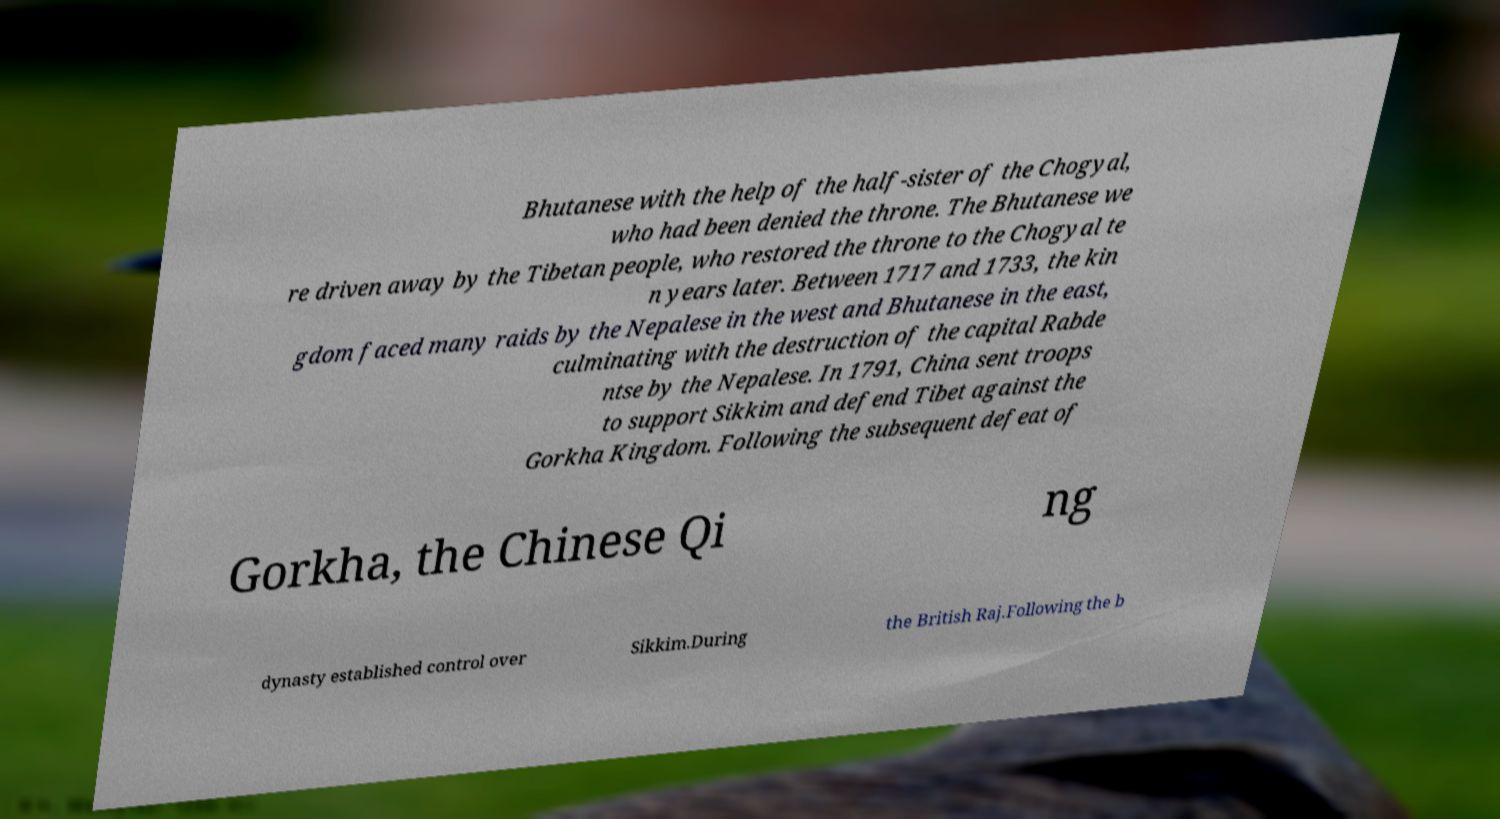I need the written content from this picture converted into text. Can you do that? Bhutanese with the help of the half-sister of the Chogyal, who had been denied the throne. The Bhutanese we re driven away by the Tibetan people, who restored the throne to the Chogyal te n years later. Between 1717 and 1733, the kin gdom faced many raids by the Nepalese in the west and Bhutanese in the east, culminating with the destruction of the capital Rabde ntse by the Nepalese. In 1791, China sent troops to support Sikkim and defend Tibet against the Gorkha Kingdom. Following the subsequent defeat of Gorkha, the Chinese Qi ng dynasty established control over Sikkim.During the British Raj.Following the b 